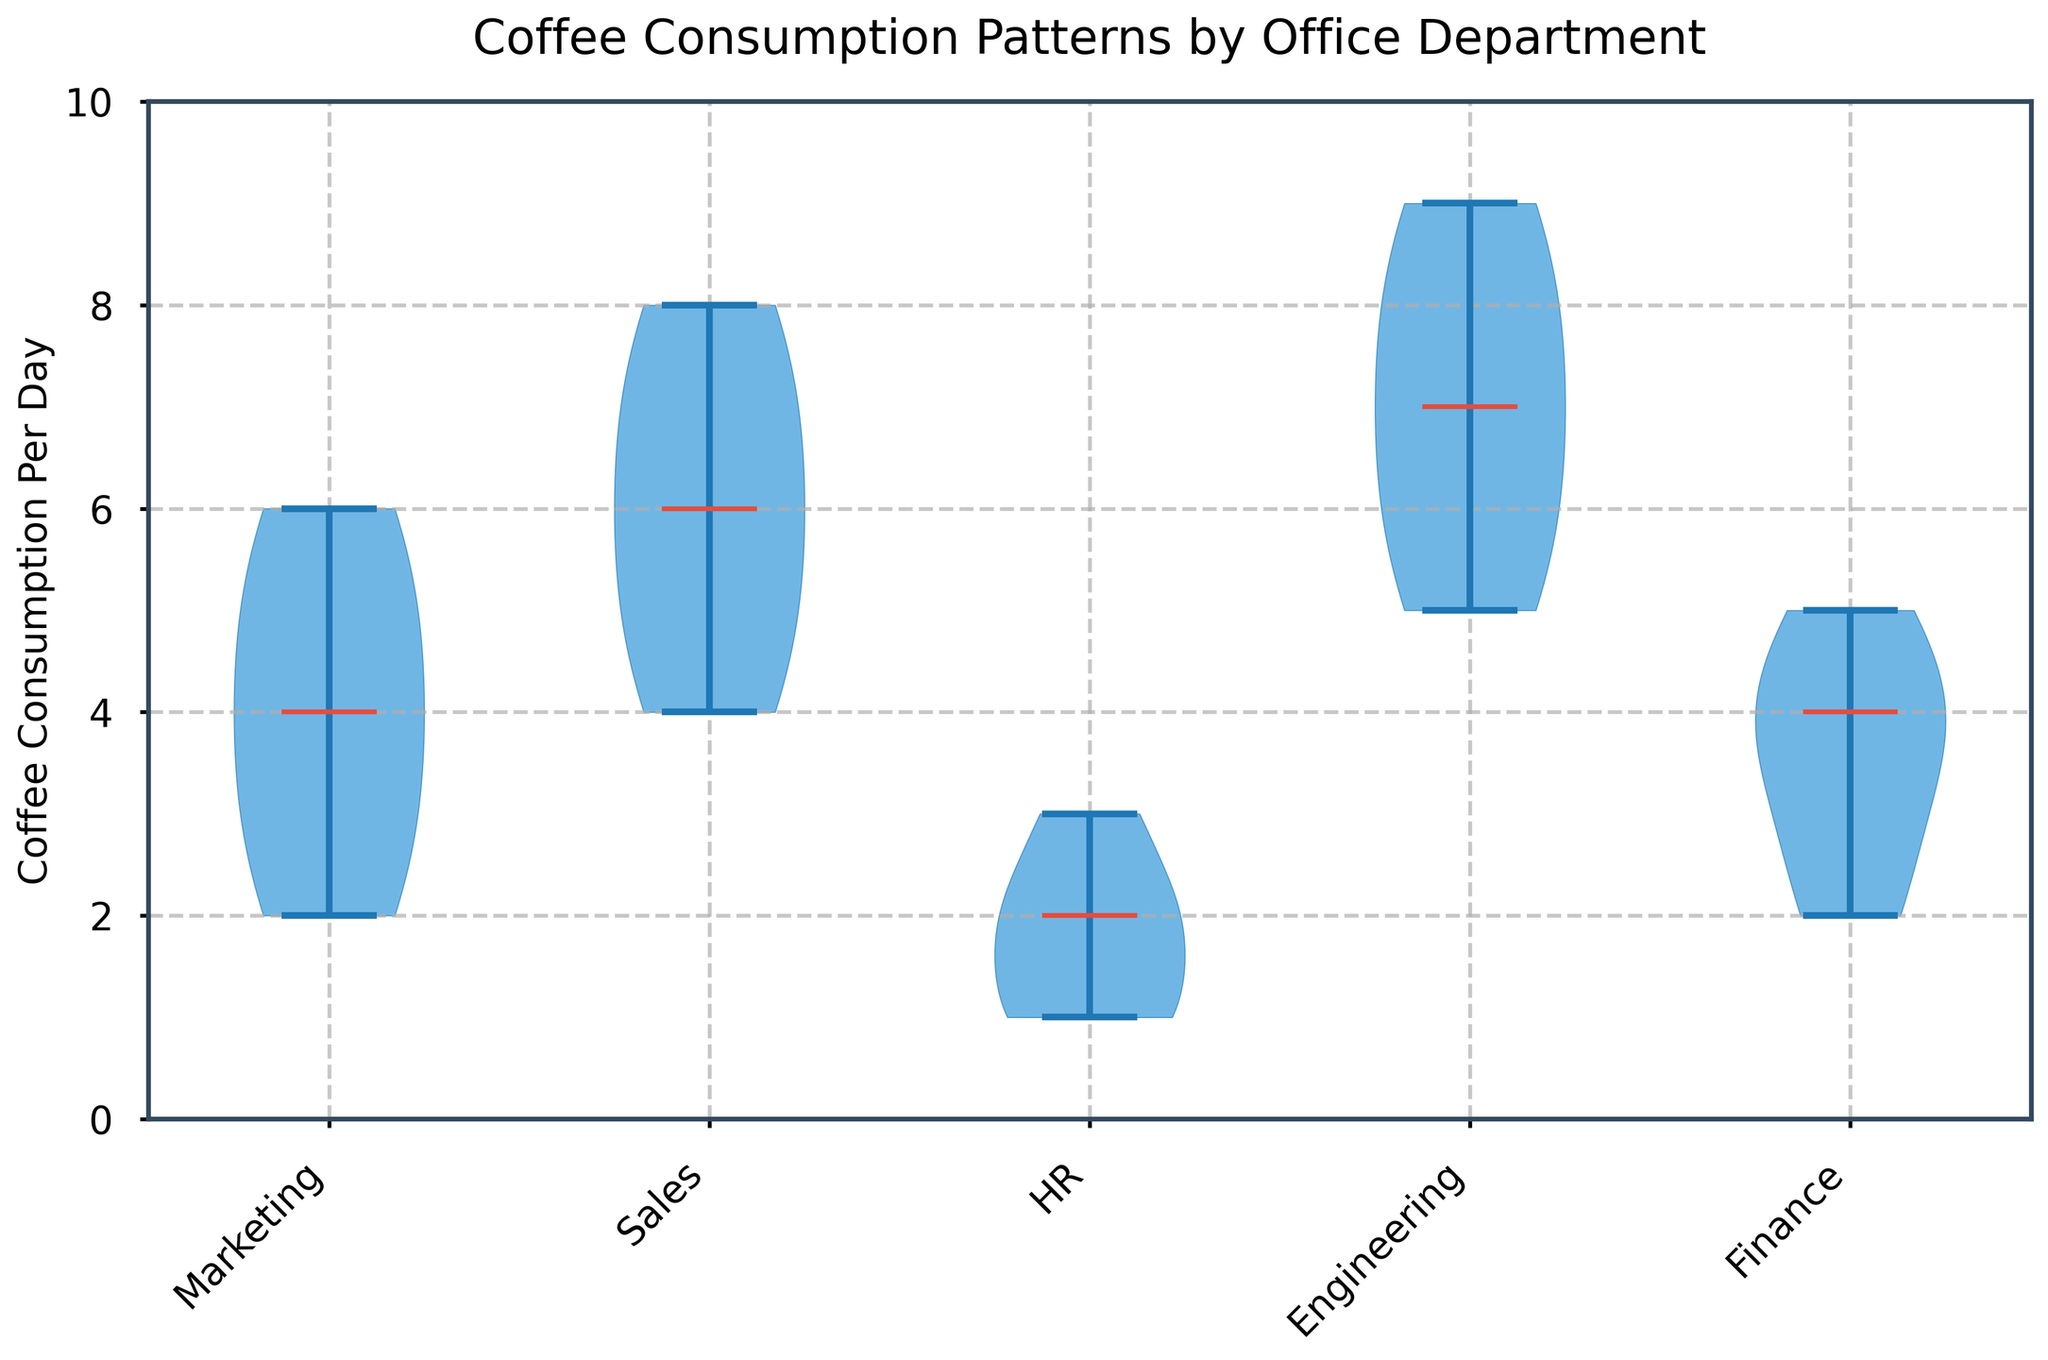What is the title of the figure? The title is usually located at the top of the figure, and it describes what the figure is about. By looking at the top, the title "Coffee Consumption Patterns by Office Department" is visible.
Answer: Coffee Consumption Patterns by Office Department What does the y-axis represent? The y-axis typically describes the variable that is being measured. In this figure, the y-axis label reads "Coffee Consumption Per Day," which indicates that it measures the number of cups of coffee consumed per day.
Answer: Coffee Consumption Per Day Which department shows the highest median coffee consumption per day? The medians of the departments are represented by horizontal lines inside the violin plots. By comparing these lines, the department with the highest one is Engineering.
Answer: Engineering What are the x-axis labels? The x-axis labels correspond to the different categories. In this plot, by looking at the bottom of the chart, the labels are "Marketing," "Sales," "HR," "Engineering," and "Finance."
Answer: Marketing, Sales, HR, Engineering, Finance Which department has the lowest range of coffee consumption per day? The range of the violin plot indicates the spread of the data. By observing the height of the violins, the HR department has the narrowest range.
Answer: HR How does the coffee consumption distribution for the HR department compare to the Finance department? For comparison, we need to look at the shape and spread of the violins. HR has a much narrower and lower distribution compared to Finance, indicating lower and more consistent coffee consumption.
Answer: HR consumes less and more consistently than Finance What's the median coffee consumption per day for Sales? The median is represented by the horizontal line within the violin plot. For Sales, this line is at about 6 cups per day.
Answer: 6 Which department has the largest interquartile range (IQR) of coffee consumption? The IQR can be visually estimated by looking at the width of the violin plot around the middle. Engineering shows the widest spread in the middle, indicating the largest IQR.
Answer: Engineering Are there any departments where the maximum coffee consumption per day exceeds 8 cups? By checking the upper tails of the violin plots, Engineering and Sales both exceed 8 cups per day at their maximum values.
Answer: Engineering, Sales 